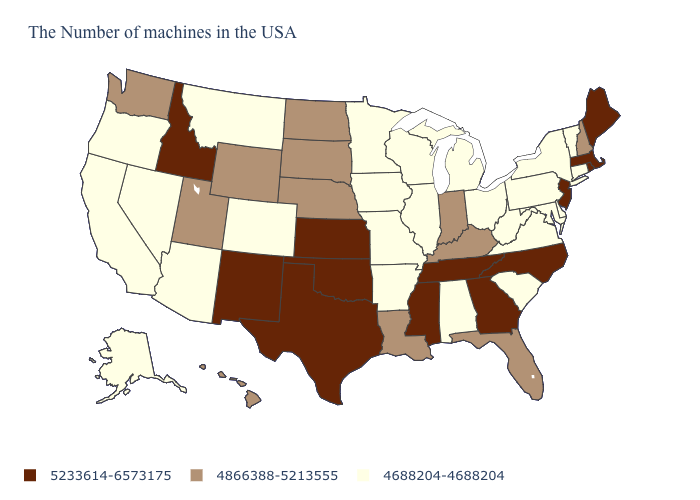Name the states that have a value in the range 4688204-4688204?
Be succinct. Vermont, Connecticut, New York, Delaware, Maryland, Pennsylvania, Virginia, South Carolina, West Virginia, Ohio, Michigan, Alabama, Wisconsin, Illinois, Missouri, Arkansas, Minnesota, Iowa, Colorado, Montana, Arizona, Nevada, California, Oregon, Alaska. Does Arizona have the highest value in the West?
Short answer required. No. Name the states that have a value in the range 4688204-4688204?
Short answer required. Vermont, Connecticut, New York, Delaware, Maryland, Pennsylvania, Virginia, South Carolina, West Virginia, Ohio, Michigan, Alabama, Wisconsin, Illinois, Missouri, Arkansas, Minnesota, Iowa, Colorado, Montana, Arizona, Nevada, California, Oregon, Alaska. What is the highest value in the USA?
Concise answer only. 5233614-6573175. What is the lowest value in the MidWest?
Answer briefly. 4688204-4688204. What is the value of New York?
Write a very short answer. 4688204-4688204. Name the states that have a value in the range 4688204-4688204?
Concise answer only. Vermont, Connecticut, New York, Delaware, Maryland, Pennsylvania, Virginia, South Carolina, West Virginia, Ohio, Michigan, Alabama, Wisconsin, Illinois, Missouri, Arkansas, Minnesota, Iowa, Colorado, Montana, Arizona, Nevada, California, Oregon, Alaska. Is the legend a continuous bar?
Be succinct. No. Which states have the highest value in the USA?
Be succinct. Maine, Massachusetts, Rhode Island, New Jersey, North Carolina, Georgia, Tennessee, Mississippi, Kansas, Oklahoma, Texas, New Mexico, Idaho. Among the states that border Minnesota , which have the highest value?
Quick response, please. South Dakota, North Dakota. What is the value of Maine?
Keep it brief. 5233614-6573175. Is the legend a continuous bar?
Keep it brief. No. Does the first symbol in the legend represent the smallest category?
Write a very short answer. No. Among the states that border Kentucky , does Missouri have the highest value?
Quick response, please. No. How many symbols are there in the legend?
Keep it brief. 3. 